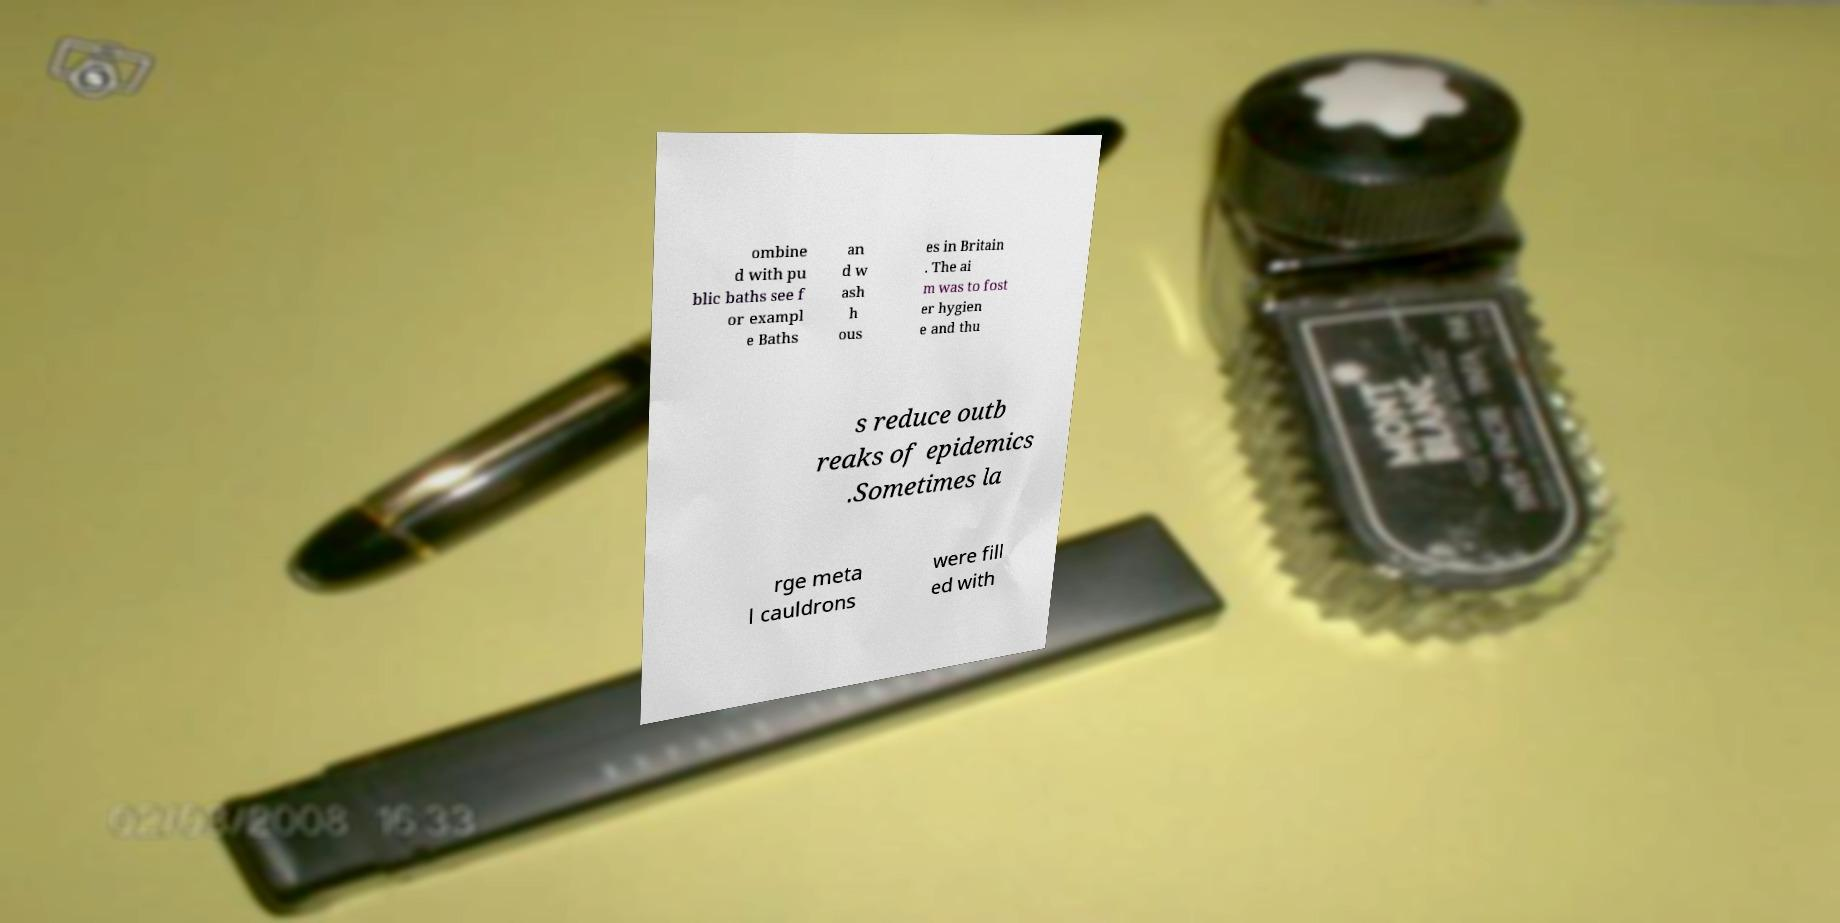Could you extract and type out the text from this image? ombine d with pu blic baths see f or exampl e Baths an d w ash h ous es in Britain . The ai m was to fost er hygien e and thu s reduce outb reaks of epidemics .Sometimes la rge meta l cauldrons were fill ed with 